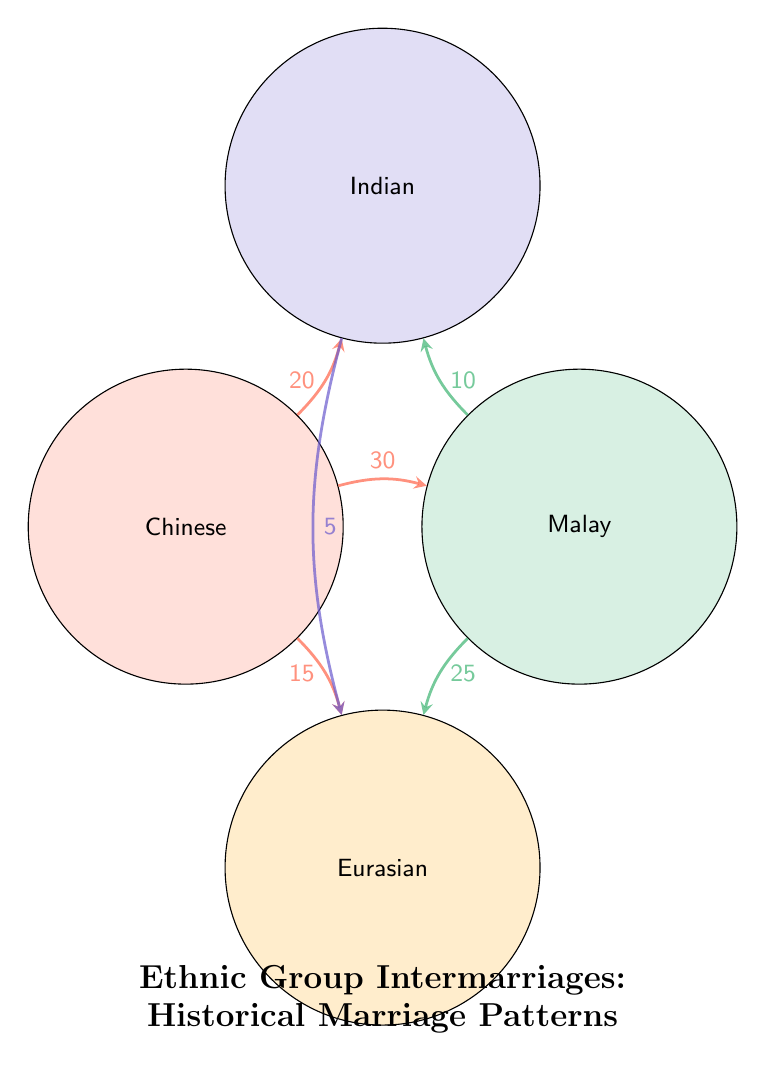What is the value of the intermarriages between Chinese and Malay? The diagram shows a connection between the Chinese and Malay nodes with a value indicated on the link. The label near the link states the value as 30.
Answer: 30 What is the total number of nodes in this diagram? The diagram contains four distinct ethnic groups represented as nodes: Chinese, Malay, Indian, and Eurasian. Counting these gives a total of four nodes.
Answer: 4 Which two communities have the lowest intermarriage value? To identify the communities with the lowest intermarriage value, we examine the link values between each pair. The link between Indian and Eurasian shows a value of 5, which is the lowest.
Answer: Indian and Eurasian What is the total number of intermarriages represented in the diagram? To find the total intermarriages, we add up all the values from the links: 30 (Chinese-Malay) + 20 (Chinese-Indian) + 15 (Chinese-Eurasian) + 10 (Malay-Indian) + 25 (Malay-Eurasian) + 5 (Indian-Eurasian) = 105.
Answer: 105 Which ethnic group has the highest number of intermarriages? By analyzing the links, we see the connections to each node: Chinese has connections significantly totaling 65 (30 + 20 + 15), Malay has 35 (30 + 10 + 25), Indian has 35 (20 + 10 + 5), and Eurasian has 40 (15 + 25 + 5). Therefore, Chinese has the highest total.
Answer: Chinese How many intermarriages are there between Malay and Indian communities? The diagram shows a direct link between the Malay and Indian communities, with a label indicating the value of this intermarriage as 10.
Answer: 10 How do the intermarriages compare between Malay and Indian to Chinese and Indian? The intermarriage between Malay and Indian has a value of 10, while the intermarriage between Chinese and Indian is higher, with a value of 20. This shows that Chinese and Indian have a stronger intermarriage connection compared to Malay and Indian.
Answer: Higher What is the strongest intermarriage link in the diagram? By reviewing all the links, the strongest connection is the one between the Chinese and Malay, with the highest value of 30 assigned to their link.
Answer: 30 Which two communities have the most direct intermarriage connections in this diagram? Reviewing the diagram, we see Chinese has three connections (to Malay, Indian, and Eurasian), while Malay has two connections (to Chinese, Indian, and Eurasian). Hence, Chinese has the most direct connections.
Answer: Chinese 